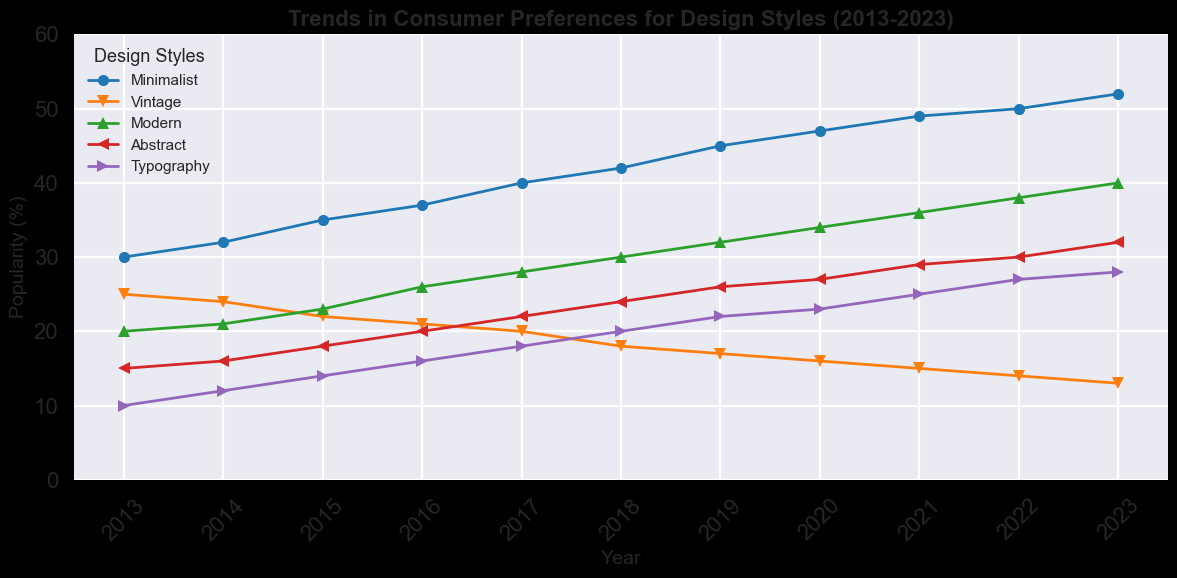What's the most popular design style in 2023? To determine the most popular design style in 2023, look at the data points corresponding to 2023 and identify the style with the highest value. Minimalist has a value of 52, which is the highest among all styles.
Answer: Minimalist Which design style had the least popularity in 2019? To find the least popular design style in 2019, check the values of all styles for that year and identify the lowest value. The values in 2019 are Minimalist: 45, Vintage: 17, Modern: 32, Abstract: 26, Typography: 22. The lowest value is 17 for Vintage.
Answer: Vintage How many percentage points did Minimalist increase from 2013 to 2023? Calculate the difference between the values of Minimalist in 2013 and 2023. The value in 2013 is 30 and in 2023 it is 52, so the increase is 52 - 30 = 22 percentage points.
Answer: 22 Which design style showed a consistent increase in popularity over the decade? Examine the trends of all design styles from 2013 to 2023 to see which one has a steadily increasing value each year. Minimalist shows a consistent increase every year.
Answer: Minimalist Compare the popularity of Modern and Abstract design styles in 2020. Which one is higher and by how much? Check the values for Modern and Abstract in 2020. Modern is 34 and Abstract is 27. Calculate the difference: 34 - 27 = 7. Therefore, Modern is higher by 7 percentage points.
Answer: Modern by 7 Between 2017 and 2018, which design style saw the largest decrease in popularity? Calculate the decrease in popularity for each style between 2017 and 2018 by subtracting the 2018 values from the 2017 values. The differences are Minimalist: 42-40=2, Vintage: 18-20=-2, Modern: 30-28=2, Abstract: 24-22=2, Typography: 20-18=2. The largest decrease is for Vintage with -2 percentage points.
Answer: Vintage What's the average popularity of Typography from 2013 to 2023? Add up the values for Typography from 2013 to 2023 and divide by the number of years. Sum is 10+12+14+16+18+20+22+23+25+27+28 = 215. Divide by 11 (years) to get the average: 215/11 ≈ 19.55.
Answer: 19.55 Which design styles' popularity values intersect at any point over the decade? If any, mention the years. By inspecting the graph, you can see if any two lines intersect. Here, Modern and Abstract intersect between the years 2015 and 2016, and Vintage and Typography intersect between 2014 and 2015.
Answer: Modern and Abstract (2015-2016), Vintage and Typography (2014-2015) In which year did Vintage first drop below 20%? Review the trend of Vintage over the years and see in which year the value falls below 20%. This happens in 2018 when the value is 18%.
Answer: 2018 